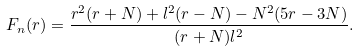Convert formula to latex. <formula><loc_0><loc_0><loc_500><loc_500>F _ { n } ( r ) = \frac { r ^ { 2 } ( r + N ) + l ^ { 2 } ( r - N ) - N ^ { 2 } ( 5 r - 3 N ) } { ( r + N ) l ^ { 2 } } .</formula> 